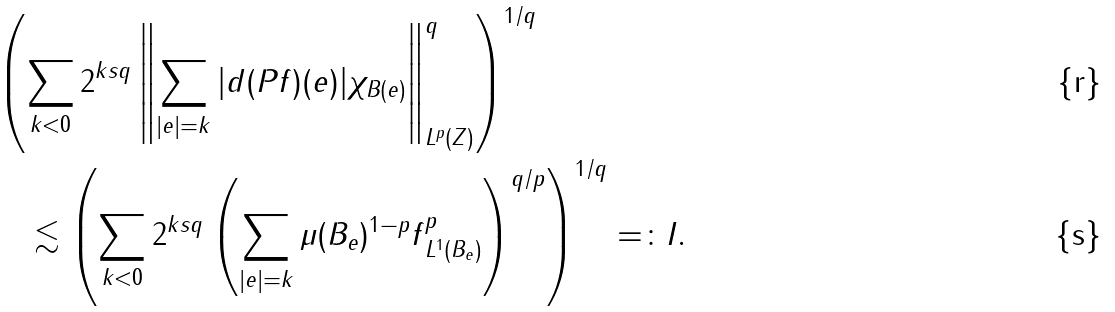Convert formula to latex. <formula><loc_0><loc_0><loc_500><loc_500>& \left ( \sum _ { k < 0 } 2 ^ { k s q } \left \| \sum _ { | e | = k } | d ( P f ) ( e ) | \chi _ { B ( e ) } \right \| _ { L ^ { p } ( Z ) } ^ { q } \right ) ^ { 1 / q } \\ & \quad \lesssim \left ( \sum _ { k < 0 } 2 ^ { k s q } \left ( \sum _ { | e | = k } \mu ( B _ { e } ) ^ { 1 - p } \| f \| _ { L ^ { 1 } ( B _ { e } ) } ^ { p } \right ) ^ { q / p } \right ) ^ { 1 / q } = \colon I .</formula> 